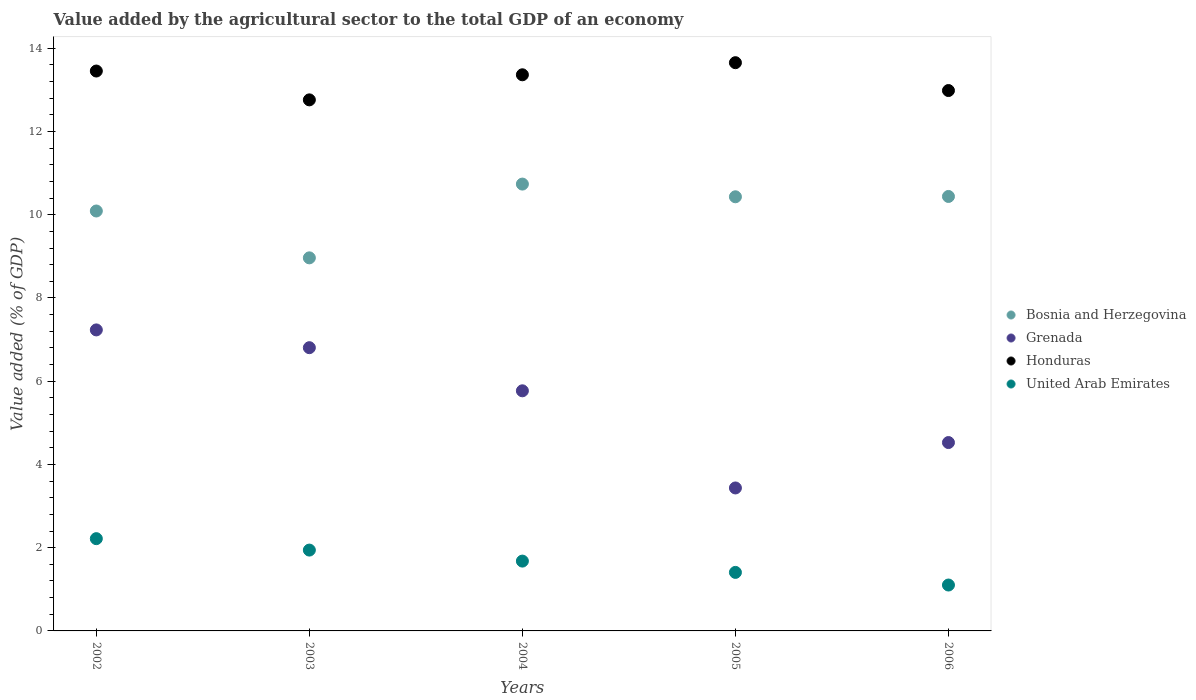How many different coloured dotlines are there?
Your response must be concise. 4. Is the number of dotlines equal to the number of legend labels?
Your response must be concise. Yes. What is the value added by the agricultural sector to the total GDP in Honduras in 2004?
Your answer should be very brief. 13.36. Across all years, what is the maximum value added by the agricultural sector to the total GDP in Grenada?
Offer a terse response. 7.23. Across all years, what is the minimum value added by the agricultural sector to the total GDP in Honduras?
Your answer should be compact. 12.76. What is the total value added by the agricultural sector to the total GDP in Bosnia and Herzegovina in the graph?
Ensure brevity in your answer.  50.66. What is the difference between the value added by the agricultural sector to the total GDP in Grenada in 2002 and that in 2006?
Your answer should be compact. 2.71. What is the difference between the value added by the agricultural sector to the total GDP in Grenada in 2006 and the value added by the agricultural sector to the total GDP in United Arab Emirates in 2003?
Provide a short and direct response. 2.58. What is the average value added by the agricultural sector to the total GDP in United Arab Emirates per year?
Your answer should be compact. 1.67. In the year 2002, what is the difference between the value added by the agricultural sector to the total GDP in Honduras and value added by the agricultural sector to the total GDP in Grenada?
Keep it short and to the point. 6.22. In how many years, is the value added by the agricultural sector to the total GDP in United Arab Emirates greater than 1.2000000000000002 %?
Make the answer very short. 4. What is the ratio of the value added by the agricultural sector to the total GDP in Grenada in 2002 to that in 2006?
Make the answer very short. 1.6. What is the difference between the highest and the second highest value added by the agricultural sector to the total GDP in Bosnia and Herzegovina?
Offer a very short reply. 0.3. What is the difference between the highest and the lowest value added by the agricultural sector to the total GDP in Grenada?
Keep it short and to the point. 3.8. In how many years, is the value added by the agricultural sector to the total GDP in Bosnia and Herzegovina greater than the average value added by the agricultural sector to the total GDP in Bosnia and Herzegovina taken over all years?
Your answer should be compact. 3. Is the sum of the value added by the agricultural sector to the total GDP in Honduras in 2002 and 2005 greater than the maximum value added by the agricultural sector to the total GDP in United Arab Emirates across all years?
Give a very brief answer. Yes. Is it the case that in every year, the sum of the value added by the agricultural sector to the total GDP in Bosnia and Herzegovina and value added by the agricultural sector to the total GDP in Honduras  is greater than the sum of value added by the agricultural sector to the total GDP in United Arab Emirates and value added by the agricultural sector to the total GDP in Grenada?
Your response must be concise. Yes. Does the value added by the agricultural sector to the total GDP in Grenada monotonically increase over the years?
Offer a terse response. No. What is the difference between two consecutive major ticks on the Y-axis?
Give a very brief answer. 2. Are the values on the major ticks of Y-axis written in scientific E-notation?
Make the answer very short. No. Does the graph contain any zero values?
Provide a short and direct response. No. Does the graph contain grids?
Ensure brevity in your answer.  No. Where does the legend appear in the graph?
Provide a short and direct response. Center right. What is the title of the graph?
Your response must be concise. Value added by the agricultural sector to the total GDP of an economy. What is the label or title of the X-axis?
Ensure brevity in your answer.  Years. What is the label or title of the Y-axis?
Give a very brief answer. Value added (% of GDP). What is the Value added (% of GDP) of Bosnia and Herzegovina in 2002?
Provide a succinct answer. 10.09. What is the Value added (% of GDP) of Grenada in 2002?
Your answer should be very brief. 7.23. What is the Value added (% of GDP) of Honduras in 2002?
Make the answer very short. 13.45. What is the Value added (% of GDP) of United Arab Emirates in 2002?
Make the answer very short. 2.22. What is the Value added (% of GDP) of Bosnia and Herzegovina in 2003?
Offer a terse response. 8.96. What is the Value added (% of GDP) in Grenada in 2003?
Make the answer very short. 6.81. What is the Value added (% of GDP) in Honduras in 2003?
Provide a succinct answer. 12.76. What is the Value added (% of GDP) of United Arab Emirates in 2003?
Your response must be concise. 1.94. What is the Value added (% of GDP) in Bosnia and Herzegovina in 2004?
Make the answer very short. 10.74. What is the Value added (% of GDP) of Grenada in 2004?
Provide a short and direct response. 5.77. What is the Value added (% of GDP) of Honduras in 2004?
Provide a short and direct response. 13.36. What is the Value added (% of GDP) of United Arab Emirates in 2004?
Your answer should be compact. 1.68. What is the Value added (% of GDP) of Bosnia and Herzegovina in 2005?
Your answer should be compact. 10.43. What is the Value added (% of GDP) in Grenada in 2005?
Offer a very short reply. 3.43. What is the Value added (% of GDP) of Honduras in 2005?
Provide a succinct answer. 13.65. What is the Value added (% of GDP) in United Arab Emirates in 2005?
Your response must be concise. 1.41. What is the Value added (% of GDP) of Bosnia and Herzegovina in 2006?
Your answer should be very brief. 10.44. What is the Value added (% of GDP) in Grenada in 2006?
Make the answer very short. 4.53. What is the Value added (% of GDP) of Honduras in 2006?
Make the answer very short. 12.98. What is the Value added (% of GDP) of United Arab Emirates in 2006?
Provide a succinct answer. 1.1. Across all years, what is the maximum Value added (% of GDP) in Bosnia and Herzegovina?
Keep it short and to the point. 10.74. Across all years, what is the maximum Value added (% of GDP) in Grenada?
Keep it short and to the point. 7.23. Across all years, what is the maximum Value added (% of GDP) in Honduras?
Your answer should be very brief. 13.65. Across all years, what is the maximum Value added (% of GDP) in United Arab Emirates?
Your answer should be very brief. 2.22. Across all years, what is the minimum Value added (% of GDP) in Bosnia and Herzegovina?
Keep it short and to the point. 8.96. Across all years, what is the minimum Value added (% of GDP) of Grenada?
Your answer should be very brief. 3.43. Across all years, what is the minimum Value added (% of GDP) of Honduras?
Offer a terse response. 12.76. Across all years, what is the minimum Value added (% of GDP) of United Arab Emirates?
Offer a very short reply. 1.1. What is the total Value added (% of GDP) in Bosnia and Herzegovina in the graph?
Provide a short and direct response. 50.66. What is the total Value added (% of GDP) in Grenada in the graph?
Make the answer very short. 27.77. What is the total Value added (% of GDP) in Honduras in the graph?
Provide a short and direct response. 66.21. What is the total Value added (% of GDP) in United Arab Emirates in the graph?
Your answer should be very brief. 8.35. What is the difference between the Value added (% of GDP) in Bosnia and Herzegovina in 2002 and that in 2003?
Your response must be concise. 1.13. What is the difference between the Value added (% of GDP) of Grenada in 2002 and that in 2003?
Offer a terse response. 0.43. What is the difference between the Value added (% of GDP) of Honduras in 2002 and that in 2003?
Make the answer very short. 0.69. What is the difference between the Value added (% of GDP) of United Arab Emirates in 2002 and that in 2003?
Your response must be concise. 0.27. What is the difference between the Value added (% of GDP) in Bosnia and Herzegovina in 2002 and that in 2004?
Give a very brief answer. -0.65. What is the difference between the Value added (% of GDP) in Grenada in 2002 and that in 2004?
Make the answer very short. 1.46. What is the difference between the Value added (% of GDP) of Honduras in 2002 and that in 2004?
Provide a short and direct response. 0.09. What is the difference between the Value added (% of GDP) of United Arab Emirates in 2002 and that in 2004?
Offer a terse response. 0.54. What is the difference between the Value added (% of GDP) in Bosnia and Herzegovina in 2002 and that in 2005?
Offer a very short reply. -0.34. What is the difference between the Value added (% of GDP) in Grenada in 2002 and that in 2005?
Give a very brief answer. 3.8. What is the difference between the Value added (% of GDP) in Honduras in 2002 and that in 2005?
Your answer should be compact. -0.2. What is the difference between the Value added (% of GDP) of United Arab Emirates in 2002 and that in 2005?
Provide a succinct answer. 0.81. What is the difference between the Value added (% of GDP) of Bosnia and Herzegovina in 2002 and that in 2006?
Provide a succinct answer. -0.35. What is the difference between the Value added (% of GDP) of Grenada in 2002 and that in 2006?
Provide a short and direct response. 2.71. What is the difference between the Value added (% of GDP) in Honduras in 2002 and that in 2006?
Provide a succinct answer. 0.47. What is the difference between the Value added (% of GDP) in United Arab Emirates in 2002 and that in 2006?
Give a very brief answer. 1.11. What is the difference between the Value added (% of GDP) in Bosnia and Herzegovina in 2003 and that in 2004?
Provide a succinct answer. -1.77. What is the difference between the Value added (% of GDP) of Grenada in 2003 and that in 2004?
Your answer should be compact. 1.04. What is the difference between the Value added (% of GDP) of Honduras in 2003 and that in 2004?
Your answer should be compact. -0.6. What is the difference between the Value added (% of GDP) in United Arab Emirates in 2003 and that in 2004?
Your answer should be compact. 0.26. What is the difference between the Value added (% of GDP) in Bosnia and Herzegovina in 2003 and that in 2005?
Ensure brevity in your answer.  -1.47. What is the difference between the Value added (% of GDP) of Grenada in 2003 and that in 2005?
Make the answer very short. 3.37. What is the difference between the Value added (% of GDP) in Honduras in 2003 and that in 2005?
Your answer should be compact. -0.89. What is the difference between the Value added (% of GDP) in United Arab Emirates in 2003 and that in 2005?
Your answer should be compact. 0.54. What is the difference between the Value added (% of GDP) of Bosnia and Herzegovina in 2003 and that in 2006?
Make the answer very short. -1.47. What is the difference between the Value added (% of GDP) in Grenada in 2003 and that in 2006?
Your answer should be very brief. 2.28. What is the difference between the Value added (% of GDP) of Honduras in 2003 and that in 2006?
Give a very brief answer. -0.22. What is the difference between the Value added (% of GDP) of United Arab Emirates in 2003 and that in 2006?
Provide a succinct answer. 0.84. What is the difference between the Value added (% of GDP) in Bosnia and Herzegovina in 2004 and that in 2005?
Keep it short and to the point. 0.31. What is the difference between the Value added (% of GDP) in Grenada in 2004 and that in 2005?
Make the answer very short. 2.33. What is the difference between the Value added (% of GDP) of Honduras in 2004 and that in 2005?
Your response must be concise. -0.29. What is the difference between the Value added (% of GDP) in United Arab Emirates in 2004 and that in 2005?
Offer a terse response. 0.27. What is the difference between the Value added (% of GDP) in Bosnia and Herzegovina in 2004 and that in 2006?
Give a very brief answer. 0.3. What is the difference between the Value added (% of GDP) in Grenada in 2004 and that in 2006?
Your response must be concise. 1.24. What is the difference between the Value added (% of GDP) of Honduras in 2004 and that in 2006?
Your answer should be very brief. 0.38. What is the difference between the Value added (% of GDP) of United Arab Emirates in 2004 and that in 2006?
Your answer should be compact. 0.57. What is the difference between the Value added (% of GDP) in Bosnia and Herzegovina in 2005 and that in 2006?
Offer a very short reply. -0.01. What is the difference between the Value added (% of GDP) in Grenada in 2005 and that in 2006?
Your answer should be very brief. -1.09. What is the difference between the Value added (% of GDP) of Honduras in 2005 and that in 2006?
Provide a succinct answer. 0.67. What is the difference between the Value added (% of GDP) in United Arab Emirates in 2005 and that in 2006?
Provide a succinct answer. 0.3. What is the difference between the Value added (% of GDP) of Bosnia and Herzegovina in 2002 and the Value added (% of GDP) of Grenada in 2003?
Provide a short and direct response. 3.28. What is the difference between the Value added (% of GDP) in Bosnia and Herzegovina in 2002 and the Value added (% of GDP) in Honduras in 2003?
Your answer should be compact. -2.67. What is the difference between the Value added (% of GDP) in Bosnia and Herzegovina in 2002 and the Value added (% of GDP) in United Arab Emirates in 2003?
Your answer should be very brief. 8.15. What is the difference between the Value added (% of GDP) in Grenada in 2002 and the Value added (% of GDP) in Honduras in 2003?
Provide a short and direct response. -5.53. What is the difference between the Value added (% of GDP) in Grenada in 2002 and the Value added (% of GDP) in United Arab Emirates in 2003?
Your response must be concise. 5.29. What is the difference between the Value added (% of GDP) of Honduras in 2002 and the Value added (% of GDP) of United Arab Emirates in 2003?
Give a very brief answer. 11.51. What is the difference between the Value added (% of GDP) of Bosnia and Herzegovina in 2002 and the Value added (% of GDP) of Grenada in 2004?
Your answer should be compact. 4.32. What is the difference between the Value added (% of GDP) in Bosnia and Herzegovina in 2002 and the Value added (% of GDP) in Honduras in 2004?
Your answer should be very brief. -3.27. What is the difference between the Value added (% of GDP) of Bosnia and Herzegovina in 2002 and the Value added (% of GDP) of United Arab Emirates in 2004?
Offer a terse response. 8.41. What is the difference between the Value added (% of GDP) in Grenada in 2002 and the Value added (% of GDP) in Honduras in 2004?
Make the answer very short. -6.13. What is the difference between the Value added (% of GDP) of Grenada in 2002 and the Value added (% of GDP) of United Arab Emirates in 2004?
Provide a succinct answer. 5.55. What is the difference between the Value added (% of GDP) of Honduras in 2002 and the Value added (% of GDP) of United Arab Emirates in 2004?
Offer a terse response. 11.77. What is the difference between the Value added (% of GDP) of Bosnia and Herzegovina in 2002 and the Value added (% of GDP) of Grenada in 2005?
Offer a terse response. 6.65. What is the difference between the Value added (% of GDP) in Bosnia and Herzegovina in 2002 and the Value added (% of GDP) in Honduras in 2005?
Your answer should be very brief. -3.56. What is the difference between the Value added (% of GDP) in Bosnia and Herzegovina in 2002 and the Value added (% of GDP) in United Arab Emirates in 2005?
Your answer should be compact. 8.68. What is the difference between the Value added (% of GDP) of Grenada in 2002 and the Value added (% of GDP) of Honduras in 2005?
Offer a terse response. -6.42. What is the difference between the Value added (% of GDP) in Grenada in 2002 and the Value added (% of GDP) in United Arab Emirates in 2005?
Offer a terse response. 5.83. What is the difference between the Value added (% of GDP) in Honduras in 2002 and the Value added (% of GDP) in United Arab Emirates in 2005?
Make the answer very short. 12.05. What is the difference between the Value added (% of GDP) in Bosnia and Herzegovina in 2002 and the Value added (% of GDP) in Grenada in 2006?
Keep it short and to the point. 5.56. What is the difference between the Value added (% of GDP) of Bosnia and Herzegovina in 2002 and the Value added (% of GDP) of Honduras in 2006?
Provide a short and direct response. -2.89. What is the difference between the Value added (% of GDP) of Bosnia and Herzegovina in 2002 and the Value added (% of GDP) of United Arab Emirates in 2006?
Make the answer very short. 8.99. What is the difference between the Value added (% of GDP) of Grenada in 2002 and the Value added (% of GDP) of Honduras in 2006?
Keep it short and to the point. -5.75. What is the difference between the Value added (% of GDP) in Grenada in 2002 and the Value added (% of GDP) in United Arab Emirates in 2006?
Ensure brevity in your answer.  6.13. What is the difference between the Value added (% of GDP) of Honduras in 2002 and the Value added (% of GDP) of United Arab Emirates in 2006?
Give a very brief answer. 12.35. What is the difference between the Value added (% of GDP) of Bosnia and Herzegovina in 2003 and the Value added (% of GDP) of Grenada in 2004?
Your answer should be compact. 3.19. What is the difference between the Value added (% of GDP) of Bosnia and Herzegovina in 2003 and the Value added (% of GDP) of Honduras in 2004?
Offer a very short reply. -4.4. What is the difference between the Value added (% of GDP) of Bosnia and Herzegovina in 2003 and the Value added (% of GDP) of United Arab Emirates in 2004?
Provide a short and direct response. 7.29. What is the difference between the Value added (% of GDP) of Grenada in 2003 and the Value added (% of GDP) of Honduras in 2004?
Your answer should be very brief. -6.56. What is the difference between the Value added (% of GDP) of Grenada in 2003 and the Value added (% of GDP) of United Arab Emirates in 2004?
Your response must be concise. 5.13. What is the difference between the Value added (% of GDP) in Honduras in 2003 and the Value added (% of GDP) in United Arab Emirates in 2004?
Keep it short and to the point. 11.08. What is the difference between the Value added (% of GDP) in Bosnia and Herzegovina in 2003 and the Value added (% of GDP) in Grenada in 2005?
Give a very brief answer. 5.53. What is the difference between the Value added (% of GDP) of Bosnia and Herzegovina in 2003 and the Value added (% of GDP) of Honduras in 2005?
Offer a very short reply. -4.69. What is the difference between the Value added (% of GDP) of Bosnia and Herzegovina in 2003 and the Value added (% of GDP) of United Arab Emirates in 2005?
Offer a very short reply. 7.56. What is the difference between the Value added (% of GDP) in Grenada in 2003 and the Value added (% of GDP) in Honduras in 2005?
Your response must be concise. -6.85. What is the difference between the Value added (% of GDP) in Grenada in 2003 and the Value added (% of GDP) in United Arab Emirates in 2005?
Your answer should be very brief. 5.4. What is the difference between the Value added (% of GDP) of Honduras in 2003 and the Value added (% of GDP) of United Arab Emirates in 2005?
Ensure brevity in your answer.  11.35. What is the difference between the Value added (% of GDP) of Bosnia and Herzegovina in 2003 and the Value added (% of GDP) of Grenada in 2006?
Make the answer very short. 4.44. What is the difference between the Value added (% of GDP) of Bosnia and Herzegovina in 2003 and the Value added (% of GDP) of Honduras in 2006?
Offer a very short reply. -4.02. What is the difference between the Value added (% of GDP) in Bosnia and Herzegovina in 2003 and the Value added (% of GDP) in United Arab Emirates in 2006?
Ensure brevity in your answer.  7.86. What is the difference between the Value added (% of GDP) in Grenada in 2003 and the Value added (% of GDP) in Honduras in 2006?
Offer a very short reply. -6.18. What is the difference between the Value added (% of GDP) of Grenada in 2003 and the Value added (% of GDP) of United Arab Emirates in 2006?
Make the answer very short. 5.7. What is the difference between the Value added (% of GDP) in Honduras in 2003 and the Value added (% of GDP) in United Arab Emirates in 2006?
Make the answer very short. 11.66. What is the difference between the Value added (% of GDP) of Bosnia and Herzegovina in 2004 and the Value added (% of GDP) of Grenada in 2005?
Give a very brief answer. 7.3. What is the difference between the Value added (% of GDP) of Bosnia and Herzegovina in 2004 and the Value added (% of GDP) of Honduras in 2005?
Your answer should be very brief. -2.92. What is the difference between the Value added (% of GDP) of Bosnia and Herzegovina in 2004 and the Value added (% of GDP) of United Arab Emirates in 2005?
Your answer should be compact. 9.33. What is the difference between the Value added (% of GDP) in Grenada in 2004 and the Value added (% of GDP) in Honduras in 2005?
Keep it short and to the point. -7.88. What is the difference between the Value added (% of GDP) in Grenada in 2004 and the Value added (% of GDP) in United Arab Emirates in 2005?
Make the answer very short. 4.36. What is the difference between the Value added (% of GDP) of Honduras in 2004 and the Value added (% of GDP) of United Arab Emirates in 2005?
Your response must be concise. 11.96. What is the difference between the Value added (% of GDP) of Bosnia and Herzegovina in 2004 and the Value added (% of GDP) of Grenada in 2006?
Give a very brief answer. 6.21. What is the difference between the Value added (% of GDP) of Bosnia and Herzegovina in 2004 and the Value added (% of GDP) of Honduras in 2006?
Your response must be concise. -2.25. What is the difference between the Value added (% of GDP) of Bosnia and Herzegovina in 2004 and the Value added (% of GDP) of United Arab Emirates in 2006?
Keep it short and to the point. 9.63. What is the difference between the Value added (% of GDP) in Grenada in 2004 and the Value added (% of GDP) in Honduras in 2006?
Provide a short and direct response. -7.21. What is the difference between the Value added (% of GDP) in Grenada in 2004 and the Value added (% of GDP) in United Arab Emirates in 2006?
Provide a short and direct response. 4.67. What is the difference between the Value added (% of GDP) in Honduras in 2004 and the Value added (% of GDP) in United Arab Emirates in 2006?
Provide a short and direct response. 12.26. What is the difference between the Value added (% of GDP) of Bosnia and Herzegovina in 2005 and the Value added (% of GDP) of Grenada in 2006?
Offer a very short reply. 5.9. What is the difference between the Value added (% of GDP) in Bosnia and Herzegovina in 2005 and the Value added (% of GDP) in Honduras in 2006?
Offer a terse response. -2.55. What is the difference between the Value added (% of GDP) in Bosnia and Herzegovina in 2005 and the Value added (% of GDP) in United Arab Emirates in 2006?
Your answer should be compact. 9.33. What is the difference between the Value added (% of GDP) in Grenada in 2005 and the Value added (% of GDP) in Honduras in 2006?
Offer a very short reply. -9.55. What is the difference between the Value added (% of GDP) in Grenada in 2005 and the Value added (% of GDP) in United Arab Emirates in 2006?
Provide a short and direct response. 2.33. What is the difference between the Value added (% of GDP) in Honduras in 2005 and the Value added (% of GDP) in United Arab Emirates in 2006?
Provide a succinct answer. 12.55. What is the average Value added (% of GDP) of Bosnia and Herzegovina per year?
Give a very brief answer. 10.13. What is the average Value added (% of GDP) of Grenada per year?
Provide a short and direct response. 5.55. What is the average Value added (% of GDP) of Honduras per year?
Provide a short and direct response. 13.24. What is the average Value added (% of GDP) of United Arab Emirates per year?
Keep it short and to the point. 1.67. In the year 2002, what is the difference between the Value added (% of GDP) in Bosnia and Herzegovina and Value added (% of GDP) in Grenada?
Your answer should be very brief. 2.86. In the year 2002, what is the difference between the Value added (% of GDP) in Bosnia and Herzegovina and Value added (% of GDP) in Honduras?
Give a very brief answer. -3.36. In the year 2002, what is the difference between the Value added (% of GDP) in Bosnia and Herzegovina and Value added (% of GDP) in United Arab Emirates?
Provide a succinct answer. 7.87. In the year 2002, what is the difference between the Value added (% of GDP) in Grenada and Value added (% of GDP) in Honduras?
Provide a short and direct response. -6.22. In the year 2002, what is the difference between the Value added (% of GDP) in Grenada and Value added (% of GDP) in United Arab Emirates?
Give a very brief answer. 5.02. In the year 2002, what is the difference between the Value added (% of GDP) of Honduras and Value added (% of GDP) of United Arab Emirates?
Provide a short and direct response. 11.24. In the year 2003, what is the difference between the Value added (% of GDP) of Bosnia and Herzegovina and Value added (% of GDP) of Grenada?
Give a very brief answer. 2.16. In the year 2003, what is the difference between the Value added (% of GDP) of Bosnia and Herzegovina and Value added (% of GDP) of Honduras?
Your answer should be very brief. -3.8. In the year 2003, what is the difference between the Value added (% of GDP) of Bosnia and Herzegovina and Value added (% of GDP) of United Arab Emirates?
Your answer should be very brief. 7.02. In the year 2003, what is the difference between the Value added (% of GDP) in Grenada and Value added (% of GDP) in Honduras?
Offer a very short reply. -5.95. In the year 2003, what is the difference between the Value added (% of GDP) of Grenada and Value added (% of GDP) of United Arab Emirates?
Provide a short and direct response. 4.86. In the year 2003, what is the difference between the Value added (% of GDP) in Honduras and Value added (% of GDP) in United Arab Emirates?
Provide a succinct answer. 10.82. In the year 2004, what is the difference between the Value added (% of GDP) of Bosnia and Herzegovina and Value added (% of GDP) of Grenada?
Ensure brevity in your answer.  4.97. In the year 2004, what is the difference between the Value added (% of GDP) in Bosnia and Herzegovina and Value added (% of GDP) in Honduras?
Offer a very short reply. -2.63. In the year 2004, what is the difference between the Value added (% of GDP) of Bosnia and Herzegovina and Value added (% of GDP) of United Arab Emirates?
Provide a succinct answer. 9.06. In the year 2004, what is the difference between the Value added (% of GDP) of Grenada and Value added (% of GDP) of Honduras?
Your answer should be very brief. -7.59. In the year 2004, what is the difference between the Value added (% of GDP) of Grenada and Value added (% of GDP) of United Arab Emirates?
Make the answer very short. 4.09. In the year 2004, what is the difference between the Value added (% of GDP) of Honduras and Value added (% of GDP) of United Arab Emirates?
Ensure brevity in your answer.  11.68. In the year 2005, what is the difference between the Value added (% of GDP) of Bosnia and Herzegovina and Value added (% of GDP) of Grenada?
Your answer should be compact. 7. In the year 2005, what is the difference between the Value added (% of GDP) of Bosnia and Herzegovina and Value added (% of GDP) of Honduras?
Ensure brevity in your answer.  -3.22. In the year 2005, what is the difference between the Value added (% of GDP) in Bosnia and Herzegovina and Value added (% of GDP) in United Arab Emirates?
Offer a terse response. 9.02. In the year 2005, what is the difference between the Value added (% of GDP) in Grenada and Value added (% of GDP) in Honduras?
Provide a short and direct response. -10.22. In the year 2005, what is the difference between the Value added (% of GDP) in Grenada and Value added (% of GDP) in United Arab Emirates?
Your response must be concise. 2.03. In the year 2005, what is the difference between the Value added (% of GDP) in Honduras and Value added (% of GDP) in United Arab Emirates?
Provide a succinct answer. 12.25. In the year 2006, what is the difference between the Value added (% of GDP) of Bosnia and Herzegovina and Value added (% of GDP) of Grenada?
Your response must be concise. 5.91. In the year 2006, what is the difference between the Value added (% of GDP) in Bosnia and Herzegovina and Value added (% of GDP) in Honduras?
Keep it short and to the point. -2.54. In the year 2006, what is the difference between the Value added (% of GDP) of Bosnia and Herzegovina and Value added (% of GDP) of United Arab Emirates?
Your answer should be compact. 9.34. In the year 2006, what is the difference between the Value added (% of GDP) in Grenada and Value added (% of GDP) in Honduras?
Your answer should be compact. -8.46. In the year 2006, what is the difference between the Value added (% of GDP) in Grenada and Value added (% of GDP) in United Arab Emirates?
Provide a succinct answer. 3.42. In the year 2006, what is the difference between the Value added (% of GDP) of Honduras and Value added (% of GDP) of United Arab Emirates?
Provide a short and direct response. 11.88. What is the ratio of the Value added (% of GDP) of Bosnia and Herzegovina in 2002 to that in 2003?
Provide a short and direct response. 1.13. What is the ratio of the Value added (% of GDP) in Grenada in 2002 to that in 2003?
Offer a terse response. 1.06. What is the ratio of the Value added (% of GDP) in Honduras in 2002 to that in 2003?
Keep it short and to the point. 1.05. What is the ratio of the Value added (% of GDP) of United Arab Emirates in 2002 to that in 2003?
Offer a terse response. 1.14. What is the ratio of the Value added (% of GDP) in Bosnia and Herzegovina in 2002 to that in 2004?
Your response must be concise. 0.94. What is the ratio of the Value added (% of GDP) in Grenada in 2002 to that in 2004?
Offer a very short reply. 1.25. What is the ratio of the Value added (% of GDP) of Honduras in 2002 to that in 2004?
Keep it short and to the point. 1.01. What is the ratio of the Value added (% of GDP) of United Arab Emirates in 2002 to that in 2004?
Make the answer very short. 1.32. What is the ratio of the Value added (% of GDP) of Bosnia and Herzegovina in 2002 to that in 2005?
Keep it short and to the point. 0.97. What is the ratio of the Value added (% of GDP) in Grenada in 2002 to that in 2005?
Provide a short and direct response. 2.11. What is the ratio of the Value added (% of GDP) of Honduras in 2002 to that in 2005?
Your answer should be very brief. 0.99. What is the ratio of the Value added (% of GDP) of United Arab Emirates in 2002 to that in 2005?
Give a very brief answer. 1.58. What is the ratio of the Value added (% of GDP) in Bosnia and Herzegovina in 2002 to that in 2006?
Provide a short and direct response. 0.97. What is the ratio of the Value added (% of GDP) in Grenada in 2002 to that in 2006?
Ensure brevity in your answer.  1.6. What is the ratio of the Value added (% of GDP) of Honduras in 2002 to that in 2006?
Keep it short and to the point. 1.04. What is the ratio of the Value added (% of GDP) of United Arab Emirates in 2002 to that in 2006?
Provide a succinct answer. 2.01. What is the ratio of the Value added (% of GDP) of Bosnia and Herzegovina in 2003 to that in 2004?
Ensure brevity in your answer.  0.83. What is the ratio of the Value added (% of GDP) of Grenada in 2003 to that in 2004?
Give a very brief answer. 1.18. What is the ratio of the Value added (% of GDP) in Honduras in 2003 to that in 2004?
Offer a very short reply. 0.95. What is the ratio of the Value added (% of GDP) of United Arab Emirates in 2003 to that in 2004?
Offer a terse response. 1.16. What is the ratio of the Value added (% of GDP) of Bosnia and Herzegovina in 2003 to that in 2005?
Your response must be concise. 0.86. What is the ratio of the Value added (% of GDP) of Grenada in 2003 to that in 2005?
Provide a short and direct response. 1.98. What is the ratio of the Value added (% of GDP) of Honduras in 2003 to that in 2005?
Make the answer very short. 0.93. What is the ratio of the Value added (% of GDP) of United Arab Emirates in 2003 to that in 2005?
Your answer should be compact. 1.38. What is the ratio of the Value added (% of GDP) in Bosnia and Herzegovina in 2003 to that in 2006?
Provide a succinct answer. 0.86. What is the ratio of the Value added (% of GDP) in Grenada in 2003 to that in 2006?
Make the answer very short. 1.5. What is the ratio of the Value added (% of GDP) of Honduras in 2003 to that in 2006?
Offer a terse response. 0.98. What is the ratio of the Value added (% of GDP) of United Arab Emirates in 2003 to that in 2006?
Provide a succinct answer. 1.76. What is the ratio of the Value added (% of GDP) in Bosnia and Herzegovina in 2004 to that in 2005?
Your answer should be very brief. 1.03. What is the ratio of the Value added (% of GDP) of Grenada in 2004 to that in 2005?
Your answer should be very brief. 1.68. What is the ratio of the Value added (% of GDP) of Honduras in 2004 to that in 2005?
Ensure brevity in your answer.  0.98. What is the ratio of the Value added (% of GDP) in United Arab Emirates in 2004 to that in 2005?
Make the answer very short. 1.19. What is the ratio of the Value added (% of GDP) of Bosnia and Herzegovina in 2004 to that in 2006?
Provide a succinct answer. 1.03. What is the ratio of the Value added (% of GDP) of Grenada in 2004 to that in 2006?
Make the answer very short. 1.27. What is the ratio of the Value added (% of GDP) in Honduras in 2004 to that in 2006?
Provide a succinct answer. 1.03. What is the ratio of the Value added (% of GDP) in United Arab Emirates in 2004 to that in 2006?
Your answer should be compact. 1.52. What is the ratio of the Value added (% of GDP) in Bosnia and Herzegovina in 2005 to that in 2006?
Your answer should be very brief. 1. What is the ratio of the Value added (% of GDP) in Grenada in 2005 to that in 2006?
Your answer should be very brief. 0.76. What is the ratio of the Value added (% of GDP) of Honduras in 2005 to that in 2006?
Your answer should be very brief. 1.05. What is the ratio of the Value added (% of GDP) in United Arab Emirates in 2005 to that in 2006?
Offer a very short reply. 1.28. What is the difference between the highest and the second highest Value added (% of GDP) of Bosnia and Herzegovina?
Give a very brief answer. 0.3. What is the difference between the highest and the second highest Value added (% of GDP) in Grenada?
Your answer should be very brief. 0.43. What is the difference between the highest and the second highest Value added (% of GDP) of Honduras?
Make the answer very short. 0.2. What is the difference between the highest and the second highest Value added (% of GDP) in United Arab Emirates?
Offer a terse response. 0.27. What is the difference between the highest and the lowest Value added (% of GDP) in Bosnia and Herzegovina?
Your answer should be very brief. 1.77. What is the difference between the highest and the lowest Value added (% of GDP) in Grenada?
Offer a very short reply. 3.8. What is the difference between the highest and the lowest Value added (% of GDP) of Honduras?
Ensure brevity in your answer.  0.89. What is the difference between the highest and the lowest Value added (% of GDP) in United Arab Emirates?
Make the answer very short. 1.11. 